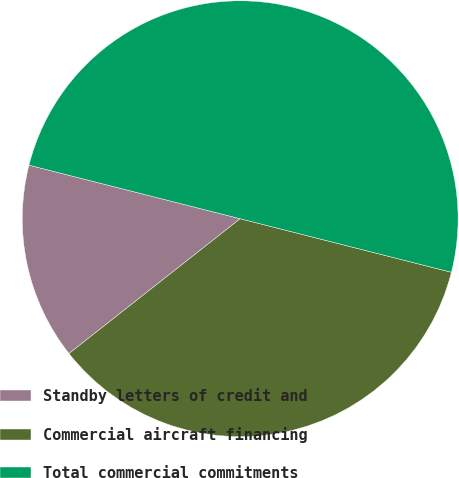Convert chart. <chart><loc_0><loc_0><loc_500><loc_500><pie_chart><fcel>Standby letters of credit and<fcel>Commercial aircraft financing<fcel>Total commercial commitments<nl><fcel>14.57%<fcel>35.43%<fcel>50.0%<nl></chart> 